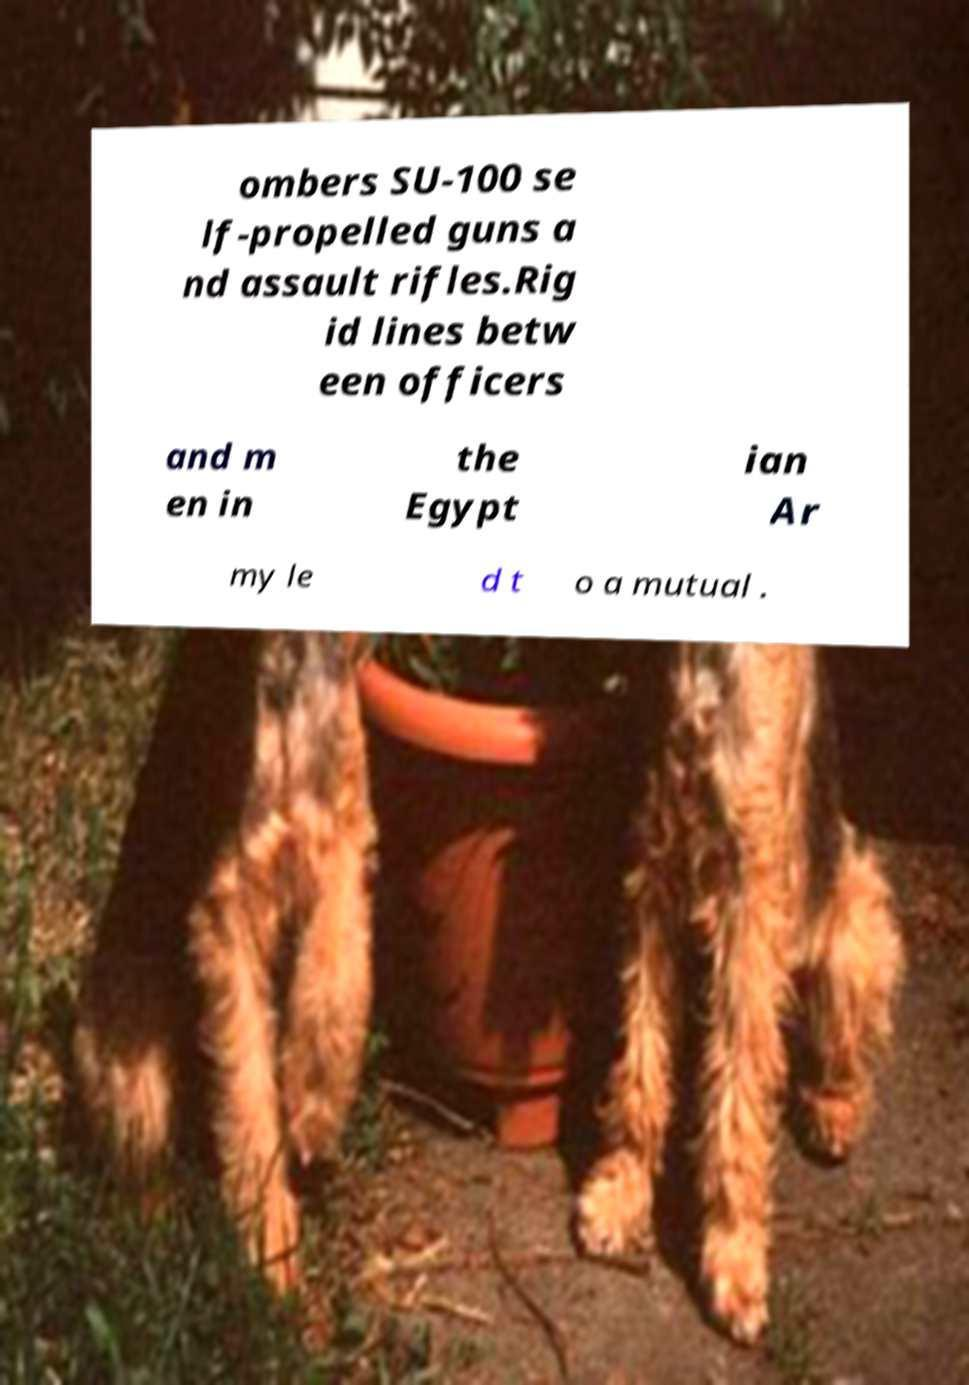I need the written content from this picture converted into text. Can you do that? ombers SU-100 se lf-propelled guns a nd assault rifles.Rig id lines betw een officers and m en in the Egypt ian Ar my le d t o a mutual . 